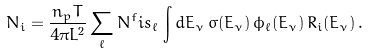<formula> <loc_0><loc_0><loc_500><loc_500>N _ { i } = \frac { n _ { p } T } { 4 \pi L ^ { 2 } } \sum _ { \ell } N ^ { f } i s _ { \ell } \, \int d E _ { \nu } \, \sigma ( E _ { \nu } ) \, \phi _ { \ell } ( E _ { \nu } ) \, R _ { i } ( E _ { \nu } ) \, .</formula> 